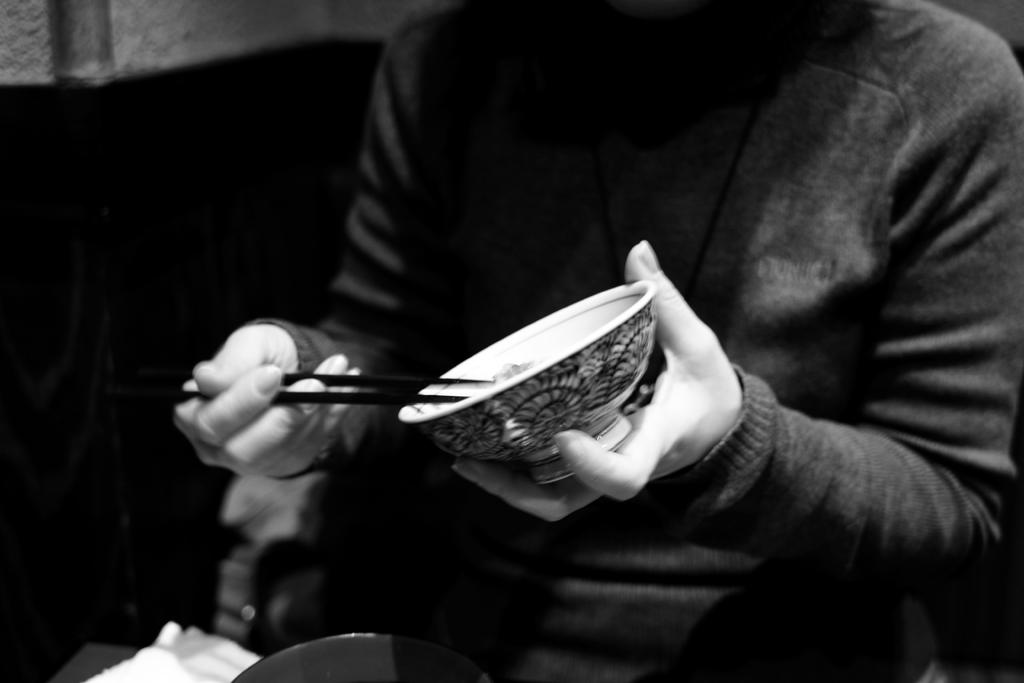Who is present in the image? There is a person in the image. What is the person holding in the image? The person is holding a bowl in the image. What is inside the bowl? There are chopsticks in the bowl. What is the person sitting on in the image? The person is sitting in a chair. What type of chalk is the person using to draw on the table in the image? There is no chalk present in the image, and the person is not drawing on the table. 